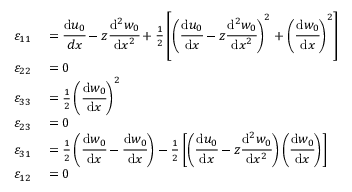<formula> <loc_0><loc_0><loc_500><loc_500>\begin{array} { r l } { \varepsilon _ { 1 1 } } & = { \cfrac { d u _ { 0 } } { d x } } - z { \cfrac { d ^ { 2 } w _ { 0 } } { d x ^ { 2 } } } + { \frac { 1 } { 2 } } \left [ \left ( { \cfrac { d u _ { 0 } } { d x } } - z { \cfrac { d ^ { 2 } w _ { 0 } } { d x ^ { 2 } } } \right ) ^ { 2 } + \left ( { \cfrac { d w _ { 0 } } { d x } } \right ) ^ { 2 } \right ] } \\ { \varepsilon _ { 2 2 } } & = 0 } \\ { \varepsilon _ { 3 3 } } & = { \frac { 1 } { 2 } } \left ( { \cfrac { d w _ { 0 } } { d x } } \right ) ^ { 2 } } \\ { \varepsilon _ { 2 3 } } & = 0 } \\ { \varepsilon _ { 3 1 } } & = { \frac { 1 } { 2 } } \left ( { \cfrac { d w _ { 0 } } { d x } } - { \cfrac { d w _ { 0 } } { d x } } \right ) - { \frac { 1 } { 2 } } \left [ \left ( { \cfrac { d u _ { 0 } } { d x } } - z { \cfrac { d ^ { 2 } w _ { 0 } } { d x ^ { 2 } } } \right ) \left ( { \cfrac { d w _ { 0 } } { d x } } \right ) \right ] } \\ { \varepsilon _ { 1 2 } } & = 0 } \end{array}</formula> 